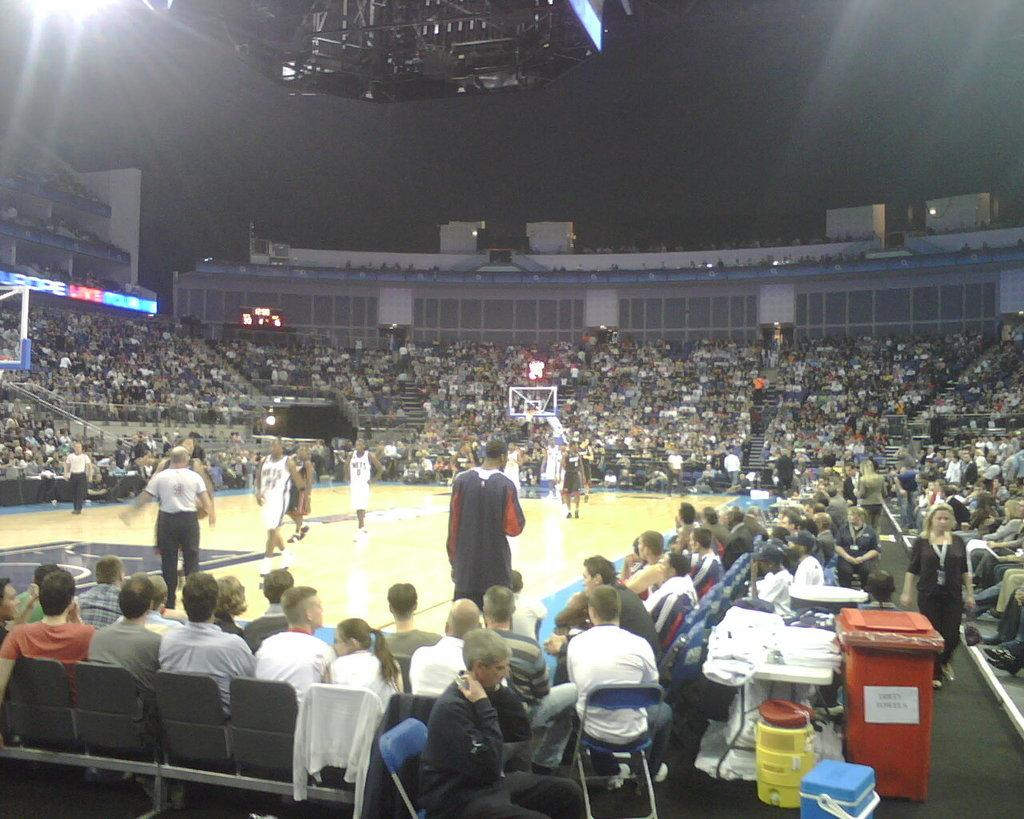What sport are the players engaged in within the image? The players are playing basketball in the image. What are the people sitting on chairs doing? The people sitting on chairs are watching the basketball players. What object is present for disposing of waste in the image? There is a dustbin in the image. What piece of furniture is present for placing objects on in the image? There is a table in the image. What can be found on the table in the image? There are items on the table. Can you see any ants crawling on the basketball players in the image? There are no ants visible in the image; the focus is on the basketball players and the people watching them. 